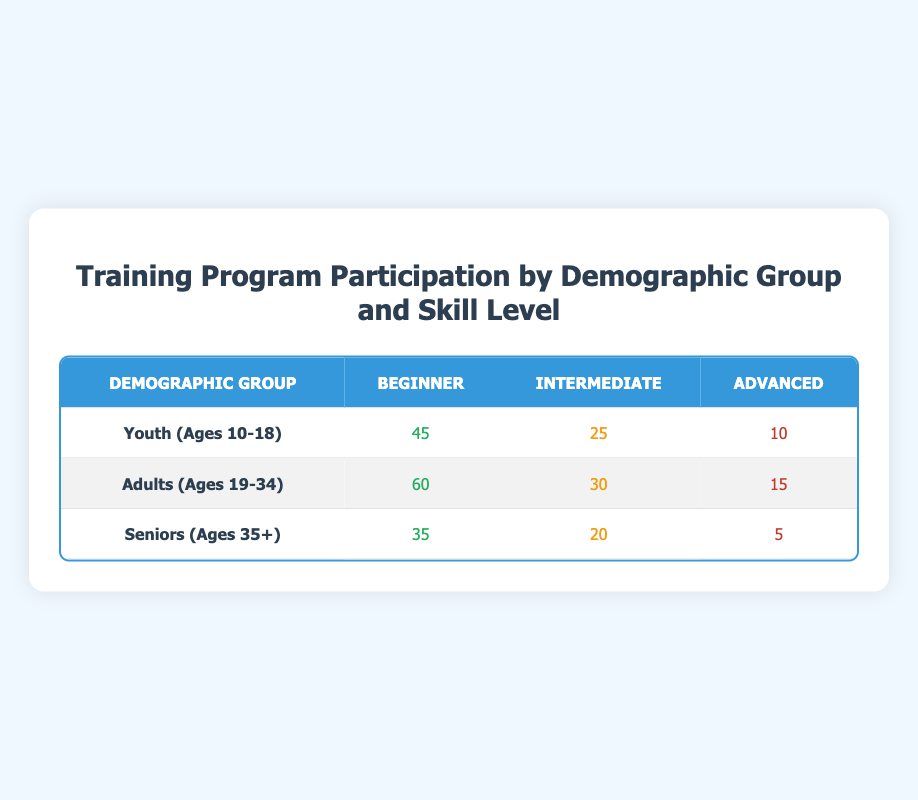What is the total number of participants in the 'Youth (Ages 10-18)' demographic group? To find the total participants in the 'Youth (Ages 10-18)' group, we add the numbers in each skill level: 45 (Beginner) + 25 (Intermediate) + 10 (Advanced) = 80.
Answer: 80 What is the number of 'Advanced' participants among 'Seniors (Ages 35+)'? The table shows that there are 5 'Advanced' participants in the 'Seniors (Ages 35+)' group, so the number is directly retrievable from that row.
Answer: 5 Do 'Adults (Ages 19-34)' have more 'Intermediate' participants than 'Youth (Ages 10-18)'? In the table, 'Adults (Ages 19-34)' have 30 'Intermediate' participants while 'Youth (Ages 10-18)' have 25 'Intermediate' participants. Since 30 is greater than 25, the statement is true.
Answer: Yes What is the total number of 'Beginner' participants across all demographic groups? To find the total number of 'Beginner' participants, we add the values from each demographic group: 45 (Youth) + 60 (Adults) + 35 (Seniors) = 140.
Answer: 140 Which demographic group has the highest number of 'Participants' for 'Intermediate' skill level? By comparing the 'Intermediate' skill levels across demographic groups from the table, 'Adults (Ages 19-34)' have 30 participants, while 'Youth (Ages 10-18)' have 25 and 'Seniors (Ages 35+)' have 20. Therefore, 'Adults (Ages 19-34)' have the highest number.
Answer: Adults (Ages 19-34) What is the average number of participants for the skill level 'Beginner' across the three demographic groups? To find the average, we first sum the participants: 45 (Youth) + 60 (Adults) + 35 (Seniors) = 140. Then we divide by the number of groups (3): 140 / 3 = approximately 46.67.
Answer: Approximately 46.67 Is there a demographic group with no 'Advanced' participants? Checking the table shows that 'Youth (Ages 10-18)', 'Adults (Ages 19-34)', and 'Seniors (Ages 35+)' all have some 'Advanced' participants present (10, 15, and 5 respectively), thus confirming that the answer is false.
Answer: No What is the difference in the number of 'Participants' between 'Seniors (Ages 35+)' and 'Youth (Ages 10-18)' for the 'Beginner' skill level? For 'Beginner' skill levels, 'Seniors (Ages 35+)' have 35 participants while 'Youth (Ages 10-18)' have 45. To find the difference: 35 - 45 = -10, indicating 'Youth' have more 'Beginner' participants.
Answer: -10 